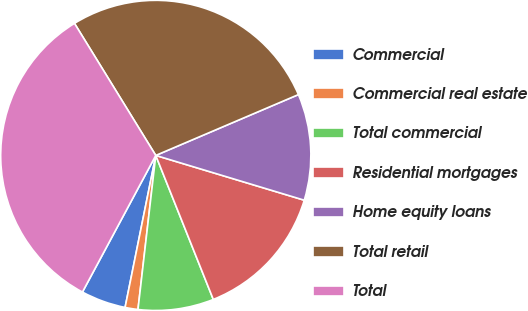Convert chart to OTSL. <chart><loc_0><loc_0><loc_500><loc_500><pie_chart><fcel>Commercial<fcel>Commercial real estate<fcel>Total commercial<fcel>Residential mortgages<fcel>Home equity loans<fcel>Total retail<fcel>Total<nl><fcel>4.67%<fcel>1.34%<fcel>7.88%<fcel>14.29%<fcel>11.08%<fcel>27.37%<fcel>33.38%<nl></chart> 